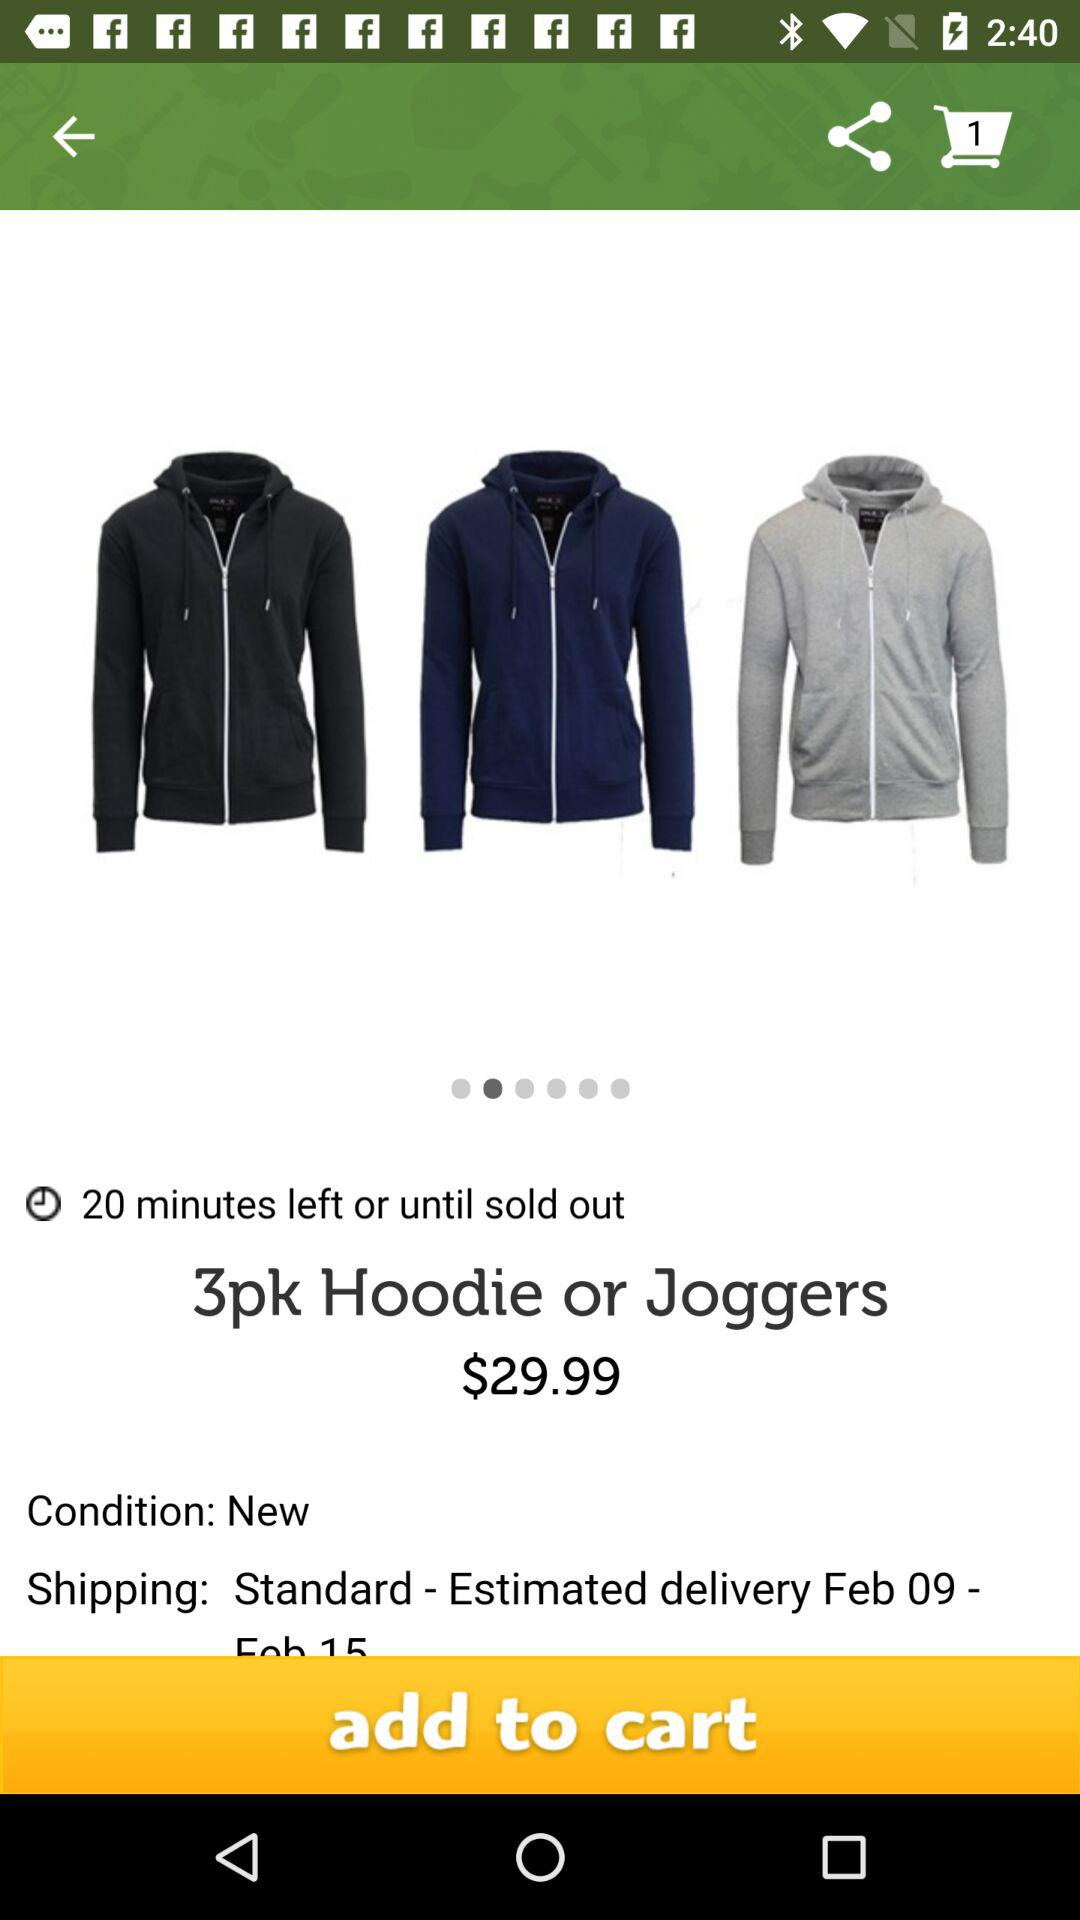What is the price of "3pk Hoodie or Joggers"? The price is $29.99. 